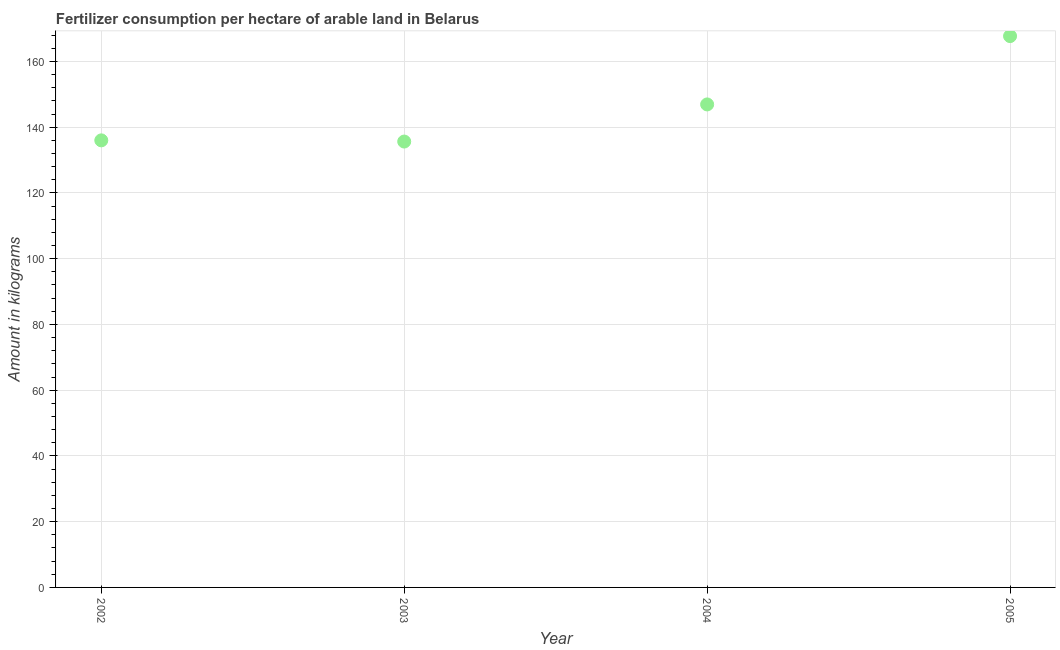What is the amount of fertilizer consumption in 2005?
Your answer should be compact. 167.7. Across all years, what is the maximum amount of fertilizer consumption?
Your response must be concise. 167.7. Across all years, what is the minimum amount of fertilizer consumption?
Your answer should be compact. 135.63. In which year was the amount of fertilizer consumption minimum?
Offer a terse response. 2003. What is the sum of the amount of fertilizer consumption?
Keep it short and to the point. 586.23. What is the difference between the amount of fertilizer consumption in 2002 and 2003?
Give a very brief answer. 0.36. What is the average amount of fertilizer consumption per year?
Make the answer very short. 146.56. What is the median amount of fertilizer consumption?
Give a very brief answer. 141.45. What is the ratio of the amount of fertilizer consumption in 2003 to that in 2004?
Keep it short and to the point. 0.92. What is the difference between the highest and the second highest amount of fertilizer consumption?
Your answer should be compact. 20.78. Is the sum of the amount of fertilizer consumption in 2002 and 2003 greater than the maximum amount of fertilizer consumption across all years?
Offer a terse response. Yes. What is the difference between the highest and the lowest amount of fertilizer consumption?
Offer a terse response. 32.08. In how many years, is the amount of fertilizer consumption greater than the average amount of fertilizer consumption taken over all years?
Keep it short and to the point. 2. Does the graph contain grids?
Make the answer very short. Yes. What is the title of the graph?
Your answer should be very brief. Fertilizer consumption per hectare of arable land in Belarus . What is the label or title of the Y-axis?
Provide a succinct answer. Amount in kilograms. What is the Amount in kilograms in 2002?
Your answer should be compact. 135.99. What is the Amount in kilograms in 2003?
Ensure brevity in your answer.  135.63. What is the Amount in kilograms in 2004?
Give a very brief answer. 146.92. What is the Amount in kilograms in 2005?
Give a very brief answer. 167.7. What is the difference between the Amount in kilograms in 2002 and 2003?
Give a very brief answer. 0.36. What is the difference between the Amount in kilograms in 2002 and 2004?
Offer a very short reply. -10.93. What is the difference between the Amount in kilograms in 2002 and 2005?
Keep it short and to the point. -31.71. What is the difference between the Amount in kilograms in 2003 and 2004?
Offer a very short reply. -11.29. What is the difference between the Amount in kilograms in 2003 and 2005?
Ensure brevity in your answer.  -32.08. What is the difference between the Amount in kilograms in 2004 and 2005?
Your answer should be very brief. -20.78. What is the ratio of the Amount in kilograms in 2002 to that in 2003?
Offer a terse response. 1. What is the ratio of the Amount in kilograms in 2002 to that in 2004?
Your response must be concise. 0.93. What is the ratio of the Amount in kilograms in 2002 to that in 2005?
Make the answer very short. 0.81. What is the ratio of the Amount in kilograms in 2003 to that in 2004?
Your answer should be very brief. 0.92. What is the ratio of the Amount in kilograms in 2003 to that in 2005?
Give a very brief answer. 0.81. What is the ratio of the Amount in kilograms in 2004 to that in 2005?
Your answer should be compact. 0.88. 